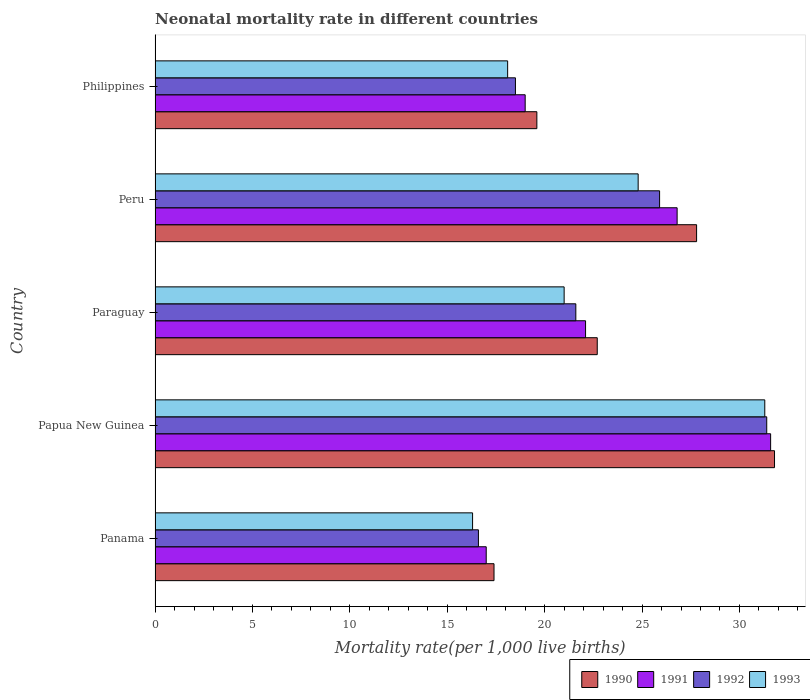How many bars are there on the 5th tick from the top?
Your answer should be compact. 4. What is the label of the 3rd group of bars from the top?
Provide a succinct answer. Paraguay. In how many cases, is the number of bars for a given country not equal to the number of legend labels?
Provide a succinct answer. 0. What is the neonatal mortality rate in 1990 in Peru?
Give a very brief answer. 27.8. Across all countries, what is the maximum neonatal mortality rate in 1990?
Your answer should be compact. 31.8. In which country was the neonatal mortality rate in 1993 maximum?
Your response must be concise. Papua New Guinea. In which country was the neonatal mortality rate in 1993 minimum?
Ensure brevity in your answer.  Panama. What is the total neonatal mortality rate in 1993 in the graph?
Offer a very short reply. 111.5. What is the difference between the neonatal mortality rate in 1991 in Papua New Guinea and that in Philippines?
Offer a terse response. 12.6. What is the difference between the neonatal mortality rate in 1992 in Papua New Guinea and the neonatal mortality rate in 1991 in Paraguay?
Offer a very short reply. 9.3. What is the average neonatal mortality rate in 1992 per country?
Offer a very short reply. 22.8. What is the difference between the neonatal mortality rate in 1992 and neonatal mortality rate in 1991 in Papua New Guinea?
Offer a terse response. -0.2. What is the ratio of the neonatal mortality rate in 1992 in Papua New Guinea to that in Paraguay?
Provide a succinct answer. 1.45. Is the neonatal mortality rate in 1990 in Panama less than that in Paraguay?
Your answer should be very brief. Yes. What is the difference between the highest and the second highest neonatal mortality rate in 1991?
Keep it short and to the point. 4.8. What is the difference between the highest and the lowest neonatal mortality rate in 1990?
Offer a terse response. 14.4. Is the sum of the neonatal mortality rate in 1991 in Panama and Paraguay greater than the maximum neonatal mortality rate in 1990 across all countries?
Provide a succinct answer. Yes. Is it the case that in every country, the sum of the neonatal mortality rate in 1991 and neonatal mortality rate in 1990 is greater than the sum of neonatal mortality rate in 1992 and neonatal mortality rate in 1993?
Ensure brevity in your answer.  No. What does the 2nd bar from the top in Paraguay represents?
Provide a short and direct response. 1992. What does the 2nd bar from the bottom in Papua New Guinea represents?
Offer a terse response. 1991. Are all the bars in the graph horizontal?
Provide a short and direct response. Yes. How many countries are there in the graph?
Give a very brief answer. 5. Does the graph contain grids?
Offer a very short reply. No. How many legend labels are there?
Ensure brevity in your answer.  4. How are the legend labels stacked?
Make the answer very short. Horizontal. What is the title of the graph?
Your answer should be very brief. Neonatal mortality rate in different countries. What is the label or title of the X-axis?
Offer a very short reply. Mortality rate(per 1,0 live births). What is the label or title of the Y-axis?
Give a very brief answer. Country. What is the Mortality rate(per 1,000 live births) in 1992 in Panama?
Make the answer very short. 16.6. What is the Mortality rate(per 1,000 live births) in 1990 in Papua New Guinea?
Your response must be concise. 31.8. What is the Mortality rate(per 1,000 live births) in 1991 in Papua New Guinea?
Provide a succinct answer. 31.6. What is the Mortality rate(per 1,000 live births) in 1992 in Papua New Guinea?
Your response must be concise. 31.4. What is the Mortality rate(per 1,000 live births) of 1993 in Papua New Guinea?
Offer a terse response. 31.3. What is the Mortality rate(per 1,000 live births) in 1990 in Paraguay?
Your response must be concise. 22.7. What is the Mortality rate(per 1,000 live births) of 1991 in Paraguay?
Keep it short and to the point. 22.1. What is the Mortality rate(per 1,000 live births) of 1992 in Paraguay?
Keep it short and to the point. 21.6. What is the Mortality rate(per 1,000 live births) of 1990 in Peru?
Make the answer very short. 27.8. What is the Mortality rate(per 1,000 live births) in 1991 in Peru?
Provide a succinct answer. 26.8. What is the Mortality rate(per 1,000 live births) in 1992 in Peru?
Keep it short and to the point. 25.9. What is the Mortality rate(per 1,000 live births) in 1993 in Peru?
Ensure brevity in your answer.  24.8. What is the Mortality rate(per 1,000 live births) of 1990 in Philippines?
Provide a short and direct response. 19.6. What is the Mortality rate(per 1,000 live births) in 1992 in Philippines?
Your response must be concise. 18.5. Across all countries, what is the maximum Mortality rate(per 1,000 live births) of 1990?
Keep it short and to the point. 31.8. Across all countries, what is the maximum Mortality rate(per 1,000 live births) in 1991?
Make the answer very short. 31.6. Across all countries, what is the maximum Mortality rate(per 1,000 live births) of 1992?
Your answer should be very brief. 31.4. Across all countries, what is the maximum Mortality rate(per 1,000 live births) of 1993?
Make the answer very short. 31.3. Across all countries, what is the minimum Mortality rate(per 1,000 live births) in 1991?
Make the answer very short. 17. What is the total Mortality rate(per 1,000 live births) in 1990 in the graph?
Offer a very short reply. 119.3. What is the total Mortality rate(per 1,000 live births) in 1991 in the graph?
Offer a very short reply. 116.5. What is the total Mortality rate(per 1,000 live births) in 1992 in the graph?
Make the answer very short. 114. What is the total Mortality rate(per 1,000 live births) of 1993 in the graph?
Offer a very short reply. 111.5. What is the difference between the Mortality rate(per 1,000 live births) of 1990 in Panama and that in Papua New Guinea?
Your answer should be compact. -14.4. What is the difference between the Mortality rate(per 1,000 live births) in 1991 in Panama and that in Papua New Guinea?
Provide a short and direct response. -14.6. What is the difference between the Mortality rate(per 1,000 live births) in 1992 in Panama and that in Papua New Guinea?
Give a very brief answer. -14.8. What is the difference between the Mortality rate(per 1,000 live births) of 1993 in Panama and that in Papua New Guinea?
Your answer should be compact. -15. What is the difference between the Mortality rate(per 1,000 live births) of 1990 in Panama and that in Paraguay?
Ensure brevity in your answer.  -5.3. What is the difference between the Mortality rate(per 1,000 live births) of 1991 in Panama and that in Paraguay?
Your answer should be very brief. -5.1. What is the difference between the Mortality rate(per 1,000 live births) in 1993 in Panama and that in Paraguay?
Offer a very short reply. -4.7. What is the difference between the Mortality rate(per 1,000 live births) in 1992 in Panama and that in Peru?
Provide a succinct answer. -9.3. What is the difference between the Mortality rate(per 1,000 live births) of 1993 in Panama and that in Peru?
Ensure brevity in your answer.  -8.5. What is the difference between the Mortality rate(per 1,000 live births) in 1990 in Panama and that in Philippines?
Your response must be concise. -2.2. What is the difference between the Mortality rate(per 1,000 live births) in 1991 in Panama and that in Philippines?
Ensure brevity in your answer.  -2. What is the difference between the Mortality rate(per 1,000 live births) of 1992 in Panama and that in Philippines?
Your answer should be very brief. -1.9. What is the difference between the Mortality rate(per 1,000 live births) of 1992 in Papua New Guinea and that in Paraguay?
Offer a terse response. 9.8. What is the difference between the Mortality rate(per 1,000 live births) of 1993 in Papua New Guinea and that in Paraguay?
Provide a succinct answer. 10.3. What is the difference between the Mortality rate(per 1,000 live births) in 1991 in Papua New Guinea and that in Peru?
Offer a very short reply. 4.8. What is the difference between the Mortality rate(per 1,000 live births) in 1990 in Papua New Guinea and that in Philippines?
Ensure brevity in your answer.  12.2. What is the difference between the Mortality rate(per 1,000 live births) of 1991 in Papua New Guinea and that in Philippines?
Provide a succinct answer. 12.6. What is the difference between the Mortality rate(per 1,000 live births) in 1992 in Papua New Guinea and that in Philippines?
Your response must be concise. 12.9. What is the difference between the Mortality rate(per 1,000 live births) of 1991 in Paraguay and that in Peru?
Offer a terse response. -4.7. What is the difference between the Mortality rate(per 1,000 live births) in 1993 in Paraguay and that in Peru?
Your answer should be compact. -3.8. What is the difference between the Mortality rate(per 1,000 live births) in 1990 in Paraguay and that in Philippines?
Offer a very short reply. 3.1. What is the difference between the Mortality rate(per 1,000 live births) in 1992 in Paraguay and that in Philippines?
Make the answer very short. 3.1. What is the difference between the Mortality rate(per 1,000 live births) of 1993 in Paraguay and that in Philippines?
Give a very brief answer. 2.9. What is the difference between the Mortality rate(per 1,000 live births) of 1992 in Peru and that in Philippines?
Provide a short and direct response. 7.4. What is the difference between the Mortality rate(per 1,000 live births) in 1993 in Peru and that in Philippines?
Make the answer very short. 6.7. What is the difference between the Mortality rate(per 1,000 live births) of 1990 in Panama and the Mortality rate(per 1,000 live births) of 1991 in Papua New Guinea?
Provide a succinct answer. -14.2. What is the difference between the Mortality rate(per 1,000 live births) in 1991 in Panama and the Mortality rate(per 1,000 live births) in 1992 in Papua New Guinea?
Provide a succinct answer. -14.4. What is the difference between the Mortality rate(per 1,000 live births) in 1991 in Panama and the Mortality rate(per 1,000 live births) in 1993 in Papua New Guinea?
Your answer should be compact. -14.3. What is the difference between the Mortality rate(per 1,000 live births) of 1992 in Panama and the Mortality rate(per 1,000 live births) of 1993 in Papua New Guinea?
Make the answer very short. -14.7. What is the difference between the Mortality rate(per 1,000 live births) in 1990 in Panama and the Mortality rate(per 1,000 live births) in 1992 in Paraguay?
Make the answer very short. -4.2. What is the difference between the Mortality rate(per 1,000 live births) in 1990 in Panama and the Mortality rate(per 1,000 live births) in 1993 in Paraguay?
Make the answer very short. -3.6. What is the difference between the Mortality rate(per 1,000 live births) of 1991 in Panama and the Mortality rate(per 1,000 live births) of 1992 in Paraguay?
Make the answer very short. -4.6. What is the difference between the Mortality rate(per 1,000 live births) of 1991 in Panama and the Mortality rate(per 1,000 live births) of 1992 in Peru?
Ensure brevity in your answer.  -8.9. What is the difference between the Mortality rate(per 1,000 live births) of 1992 in Panama and the Mortality rate(per 1,000 live births) of 1993 in Peru?
Provide a short and direct response. -8.2. What is the difference between the Mortality rate(per 1,000 live births) of 1990 in Panama and the Mortality rate(per 1,000 live births) of 1992 in Philippines?
Your answer should be very brief. -1.1. What is the difference between the Mortality rate(per 1,000 live births) in 1991 in Panama and the Mortality rate(per 1,000 live births) in 1992 in Philippines?
Ensure brevity in your answer.  -1.5. What is the difference between the Mortality rate(per 1,000 live births) of 1992 in Panama and the Mortality rate(per 1,000 live births) of 1993 in Philippines?
Your answer should be compact. -1.5. What is the difference between the Mortality rate(per 1,000 live births) in 1990 in Papua New Guinea and the Mortality rate(per 1,000 live births) in 1992 in Paraguay?
Keep it short and to the point. 10.2. What is the difference between the Mortality rate(per 1,000 live births) of 1990 in Papua New Guinea and the Mortality rate(per 1,000 live births) of 1993 in Paraguay?
Keep it short and to the point. 10.8. What is the difference between the Mortality rate(per 1,000 live births) of 1992 in Papua New Guinea and the Mortality rate(per 1,000 live births) of 1993 in Paraguay?
Your answer should be compact. 10.4. What is the difference between the Mortality rate(per 1,000 live births) in 1990 in Papua New Guinea and the Mortality rate(per 1,000 live births) in 1991 in Peru?
Your answer should be very brief. 5. What is the difference between the Mortality rate(per 1,000 live births) in 1991 in Papua New Guinea and the Mortality rate(per 1,000 live births) in 1993 in Peru?
Your answer should be compact. 6.8. What is the difference between the Mortality rate(per 1,000 live births) in 1990 in Papua New Guinea and the Mortality rate(per 1,000 live births) in 1992 in Philippines?
Your answer should be compact. 13.3. What is the difference between the Mortality rate(per 1,000 live births) in 1990 in Papua New Guinea and the Mortality rate(per 1,000 live births) in 1993 in Philippines?
Your answer should be very brief. 13.7. What is the difference between the Mortality rate(per 1,000 live births) of 1991 in Papua New Guinea and the Mortality rate(per 1,000 live births) of 1992 in Philippines?
Provide a short and direct response. 13.1. What is the difference between the Mortality rate(per 1,000 live births) of 1991 in Papua New Guinea and the Mortality rate(per 1,000 live births) of 1993 in Philippines?
Keep it short and to the point. 13.5. What is the difference between the Mortality rate(per 1,000 live births) of 1990 in Paraguay and the Mortality rate(per 1,000 live births) of 1991 in Peru?
Your answer should be compact. -4.1. What is the difference between the Mortality rate(per 1,000 live births) in 1990 in Paraguay and the Mortality rate(per 1,000 live births) in 1993 in Peru?
Your answer should be very brief. -2.1. What is the difference between the Mortality rate(per 1,000 live births) in 1991 in Paraguay and the Mortality rate(per 1,000 live births) in 1993 in Peru?
Keep it short and to the point. -2.7. What is the difference between the Mortality rate(per 1,000 live births) of 1992 in Paraguay and the Mortality rate(per 1,000 live births) of 1993 in Peru?
Your response must be concise. -3.2. What is the difference between the Mortality rate(per 1,000 live births) in 1990 in Paraguay and the Mortality rate(per 1,000 live births) in 1991 in Philippines?
Provide a succinct answer. 3.7. What is the difference between the Mortality rate(per 1,000 live births) in 1991 in Paraguay and the Mortality rate(per 1,000 live births) in 1992 in Philippines?
Provide a short and direct response. 3.6. What is the difference between the Mortality rate(per 1,000 live births) of 1990 in Peru and the Mortality rate(per 1,000 live births) of 1991 in Philippines?
Make the answer very short. 8.8. What is the difference between the Mortality rate(per 1,000 live births) in 1990 in Peru and the Mortality rate(per 1,000 live births) in 1992 in Philippines?
Provide a succinct answer. 9.3. What is the difference between the Mortality rate(per 1,000 live births) in 1991 in Peru and the Mortality rate(per 1,000 live births) in 1992 in Philippines?
Offer a very short reply. 8.3. What is the average Mortality rate(per 1,000 live births) in 1990 per country?
Offer a terse response. 23.86. What is the average Mortality rate(per 1,000 live births) of 1991 per country?
Give a very brief answer. 23.3. What is the average Mortality rate(per 1,000 live births) in 1992 per country?
Your response must be concise. 22.8. What is the average Mortality rate(per 1,000 live births) in 1993 per country?
Your answer should be very brief. 22.3. What is the difference between the Mortality rate(per 1,000 live births) in 1990 and Mortality rate(per 1,000 live births) in 1992 in Panama?
Make the answer very short. 0.8. What is the difference between the Mortality rate(per 1,000 live births) in 1990 and Mortality rate(per 1,000 live births) in 1993 in Panama?
Ensure brevity in your answer.  1.1. What is the difference between the Mortality rate(per 1,000 live births) in 1991 and Mortality rate(per 1,000 live births) in 1993 in Panama?
Your answer should be compact. 0.7. What is the difference between the Mortality rate(per 1,000 live births) of 1990 and Mortality rate(per 1,000 live births) of 1991 in Papua New Guinea?
Your response must be concise. 0.2. What is the difference between the Mortality rate(per 1,000 live births) in 1990 and Mortality rate(per 1,000 live births) in 1992 in Papua New Guinea?
Provide a succinct answer. 0.4. What is the difference between the Mortality rate(per 1,000 live births) of 1990 and Mortality rate(per 1,000 live births) of 1993 in Papua New Guinea?
Offer a terse response. 0.5. What is the difference between the Mortality rate(per 1,000 live births) of 1990 and Mortality rate(per 1,000 live births) of 1992 in Paraguay?
Give a very brief answer. 1.1. What is the difference between the Mortality rate(per 1,000 live births) of 1990 and Mortality rate(per 1,000 live births) of 1993 in Paraguay?
Keep it short and to the point. 1.7. What is the difference between the Mortality rate(per 1,000 live births) of 1991 and Mortality rate(per 1,000 live births) of 1992 in Paraguay?
Keep it short and to the point. 0.5. What is the difference between the Mortality rate(per 1,000 live births) of 1992 and Mortality rate(per 1,000 live births) of 1993 in Paraguay?
Keep it short and to the point. 0.6. What is the difference between the Mortality rate(per 1,000 live births) of 1990 and Mortality rate(per 1,000 live births) of 1991 in Peru?
Keep it short and to the point. 1. What is the difference between the Mortality rate(per 1,000 live births) of 1990 and Mortality rate(per 1,000 live births) of 1993 in Peru?
Provide a short and direct response. 3. What is the difference between the Mortality rate(per 1,000 live births) in 1990 and Mortality rate(per 1,000 live births) in 1991 in Philippines?
Offer a terse response. 0.6. What is the difference between the Mortality rate(per 1,000 live births) of 1991 and Mortality rate(per 1,000 live births) of 1992 in Philippines?
Your response must be concise. 0.5. What is the ratio of the Mortality rate(per 1,000 live births) in 1990 in Panama to that in Papua New Guinea?
Keep it short and to the point. 0.55. What is the ratio of the Mortality rate(per 1,000 live births) of 1991 in Panama to that in Papua New Guinea?
Give a very brief answer. 0.54. What is the ratio of the Mortality rate(per 1,000 live births) of 1992 in Panama to that in Papua New Guinea?
Ensure brevity in your answer.  0.53. What is the ratio of the Mortality rate(per 1,000 live births) in 1993 in Panama to that in Papua New Guinea?
Your response must be concise. 0.52. What is the ratio of the Mortality rate(per 1,000 live births) in 1990 in Panama to that in Paraguay?
Your answer should be very brief. 0.77. What is the ratio of the Mortality rate(per 1,000 live births) of 1991 in Panama to that in Paraguay?
Offer a very short reply. 0.77. What is the ratio of the Mortality rate(per 1,000 live births) in 1992 in Panama to that in Paraguay?
Make the answer very short. 0.77. What is the ratio of the Mortality rate(per 1,000 live births) in 1993 in Panama to that in Paraguay?
Provide a short and direct response. 0.78. What is the ratio of the Mortality rate(per 1,000 live births) in 1990 in Panama to that in Peru?
Offer a very short reply. 0.63. What is the ratio of the Mortality rate(per 1,000 live births) of 1991 in Panama to that in Peru?
Provide a succinct answer. 0.63. What is the ratio of the Mortality rate(per 1,000 live births) of 1992 in Panama to that in Peru?
Your answer should be very brief. 0.64. What is the ratio of the Mortality rate(per 1,000 live births) in 1993 in Panama to that in Peru?
Offer a terse response. 0.66. What is the ratio of the Mortality rate(per 1,000 live births) of 1990 in Panama to that in Philippines?
Provide a succinct answer. 0.89. What is the ratio of the Mortality rate(per 1,000 live births) of 1991 in Panama to that in Philippines?
Ensure brevity in your answer.  0.89. What is the ratio of the Mortality rate(per 1,000 live births) in 1992 in Panama to that in Philippines?
Your answer should be very brief. 0.9. What is the ratio of the Mortality rate(per 1,000 live births) in 1993 in Panama to that in Philippines?
Provide a short and direct response. 0.9. What is the ratio of the Mortality rate(per 1,000 live births) of 1990 in Papua New Guinea to that in Paraguay?
Your answer should be very brief. 1.4. What is the ratio of the Mortality rate(per 1,000 live births) of 1991 in Papua New Guinea to that in Paraguay?
Keep it short and to the point. 1.43. What is the ratio of the Mortality rate(per 1,000 live births) of 1992 in Papua New Guinea to that in Paraguay?
Your answer should be very brief. 1.45. What is the ratio of the Mortality rate(per 1,000 live births) of 1993 in Papua New Guinea to that in Paraguay?
Give a very brief answer. 1.49. What is the ratio of the Mortality rate(per 1,000 live births) of 1990 in Papua New Guinea to that in Peru?
Your answer should be very brief. 1.14. What is the ratio of the Mortality rate(per 1,000 live births) of 1991 in Papua New Guinea to that in Peru?
Provide a short and direct response. 1.18. What is the ratio of the Mortality rate(per 1,000 live births) of 1992 in Papua New Guinea to that in Peru?
Your response must be concise. 1.21. What is the ratio of the Mortality rate(per 1,000 live births) of 1993 in Papua New Guinea to that in Peru?
Offer a terse response. 1.26. What is the ratio of the Mortality rate(per 1,000 live births) of 1990 in Papua New Guinea to that in Philippines?
Provide a short and direct response. 1.62. What is the ratio of the Mortality rate(per 1,000 live births) of 1991 in Papua New Guinea to that in Philippines?
Your answer should be compact. 1.66. What is the ratio of the Mortality rate(per 1,000 live births) in 1992 in Papua New Guinea to that in Philippines?
Give a very brief answer. 1.7. What is the ratio of the Mortality rate(per 1,000 live births) of 1993 in Papua New Guinea to that in Philippines?
Keep it short and to the point. 1.73. What is the ratio of the Mortality rate(per 1,000 live births) in 1990 in Paraguay to that in Peru?
Provide a short and direct response. 0.82. What is the ratio of the Mortality rate(per 1,000 live births) of 1991 in Paraguay to that in Peru?
Your answer should be compact. 0.82. What is the ratio of the Mortality rate(per 1,000 live births) in 1992 in Paraguay to that in Peru?
Offer a very short reply. 0.83. What is the ratio of the Mortality rate(per 1,000 live births) of 1993 in Paraguay to that in Peru?
Make the answer very short. 0.85. What is the ratio of the Mortality rate(per 1,000 live births) of 1990 in Paraguay to that in Philippines?
Provide a short and direct response. 1.16. What is the ratio of the Mortality rate(per 1,000 live births) in 1991 in Paraguay to that in Philippines?
Give a very brief answer. 1.16. What is the ratio of the Mortality rate(per 1,000 live births) of 1992 in Paraguay to that in Philippines?
Your answer should be very brief. 1.17. What is the ratio of the Mortality rate(per 1,000 live births) in 1993 in Paraguay to that in Philippines?
Offer a terse response. 1.16. What is the ratio of the Mortality rate(per 1,000 live births) of 1990 in Peru to that in Philippines?
Your answer should be very brief. 1.42. What is the ratio of the Mortality rate(per 1,000 live births) of 1991 in Peru to that in Philippines?
Give a very brief answer. 1.41. What is the ratio of the Mortality rate(per 1,000 live births) of 1992 in Peru to that in Philippines?
Your answer should be compact. 1.4. What is the ratio of the Mortality rate(per 1,000 live births) of 1993 in Peru to that in Philippines?
Keep it short and to the point. 1.37. What is the difference between the highest and the second highest Mortality rate(per 1,000 live births) of 1990?
Your answer should be compact. 4. What is the difference between the highest and the second highest Mortality rate(per 1,000 live births) in 1992?
Provide a succinct answer. 5.5. What is the difference between the highest and the lowest Mortality rate(per 1,000 live births) of 1990?
Your answer should be compact. 14.4. What is the difference between the highest and the lowest Mortality rate(per 1,000 live births) of 1993?
Your answer should be compact. 15. 